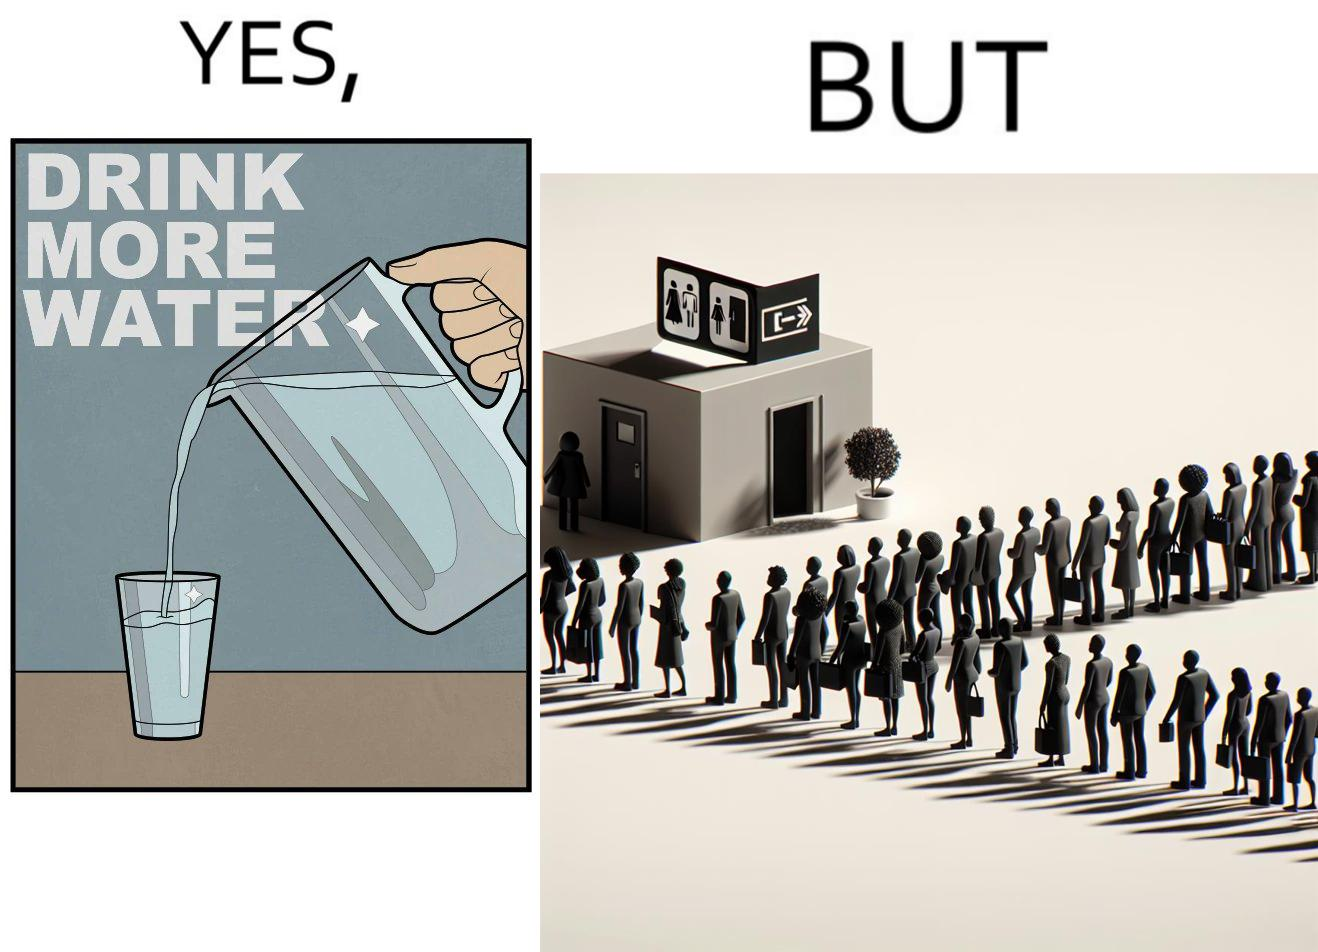Describe what you see in this image. The image is ironical, as the message "Drink more water" is meant to improve health, but in turn, it would lead to longer queues in front of public toilets, leading to people holding urine for longer periods, in turn leading to deterioration in health. 